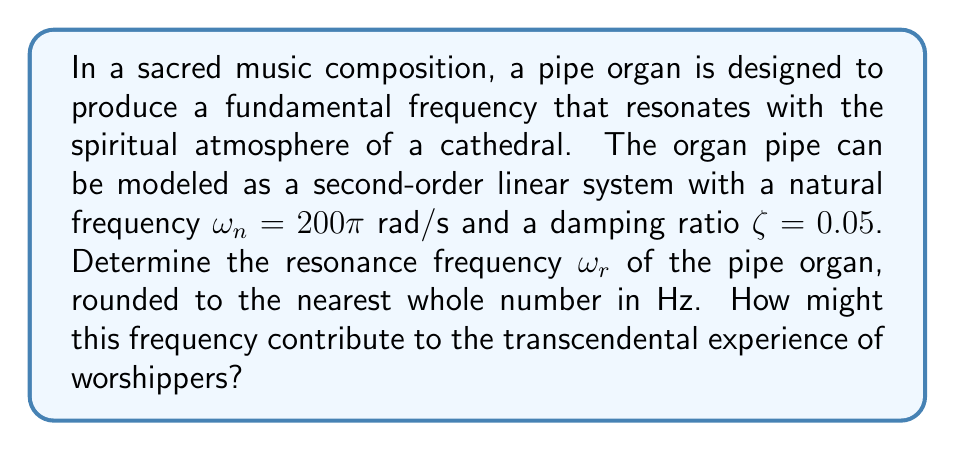Teach me how to tackle this problem. To determine the resonance frequency of the pipe organ, we'll use the formula for resonance frequency in a second-order linear system:

$$\omega_r = \omega_n \sqrt{1 - 2\zeta^2}$$

Where:
$\omega_r$ is the resonance frequency (rad/s)
$\omega_n$ is the natural frequency (rad/s)
$\zeta$ is the damping ratio

Given:
$\omega_n = 200\pi$ rad/s
$\zeta = 0.05$

Step 1: Substitute the values into the formula:
$$\omega_r = 200\pi \sqrt{1 - 2(0.05)^2}$$

Step 2: Simplify the expression under the square root:
$$\omega_r = 200\pi \sqrt{1 - 0.005}$$
$$\omega_r = 200\pi \sqrt{0.995}$$

Step 3: Calculate the result:
$$\omega_r \approx 628.25 \text{ rad/s}$$

Step 4: Convert from rad/s to Hz by dividing by $2\pi$:
$$f_r = \frac{\omega_r}{2\pi} \approx \frac{628.25}{2\pi} \approx 99.97 \text{ Hz}$$

Step 5: Round to the nearest whole number:
$$f_r \approx 100 \text{ Hz}$$

This frequency, being in the lower range of human hearing, could contribute to a sense of depth and resonance in the worship space, potentially enhancing the spiritual experience of the congregation.
Answer: The resonance frequency of the pipe organ is approximately 100 Hz. 